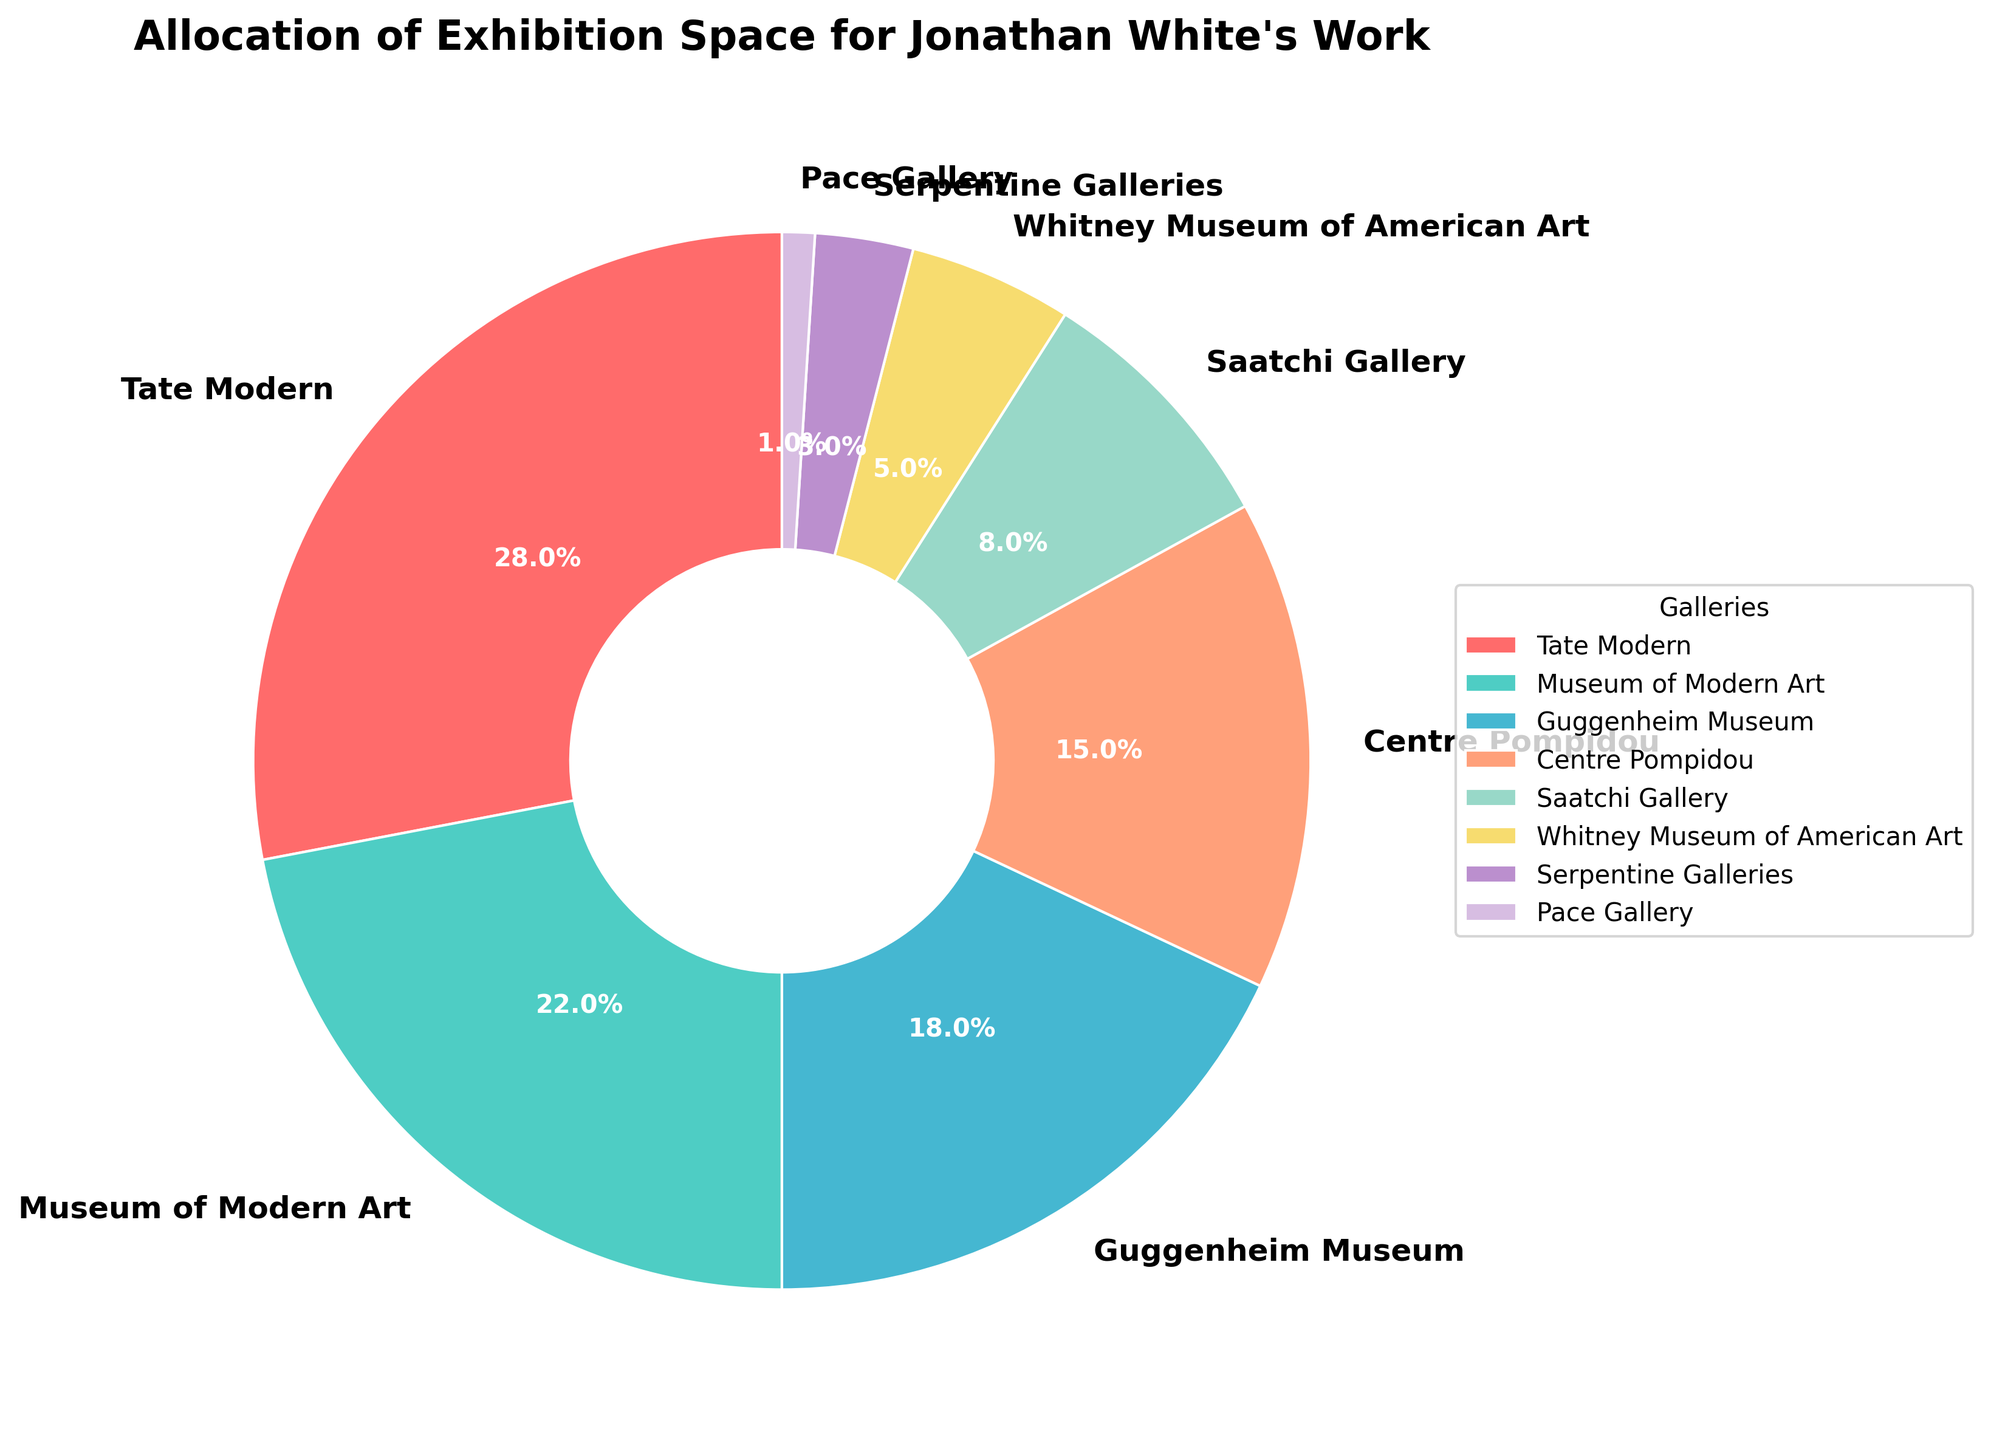Which gallery allocates the largest exhibition space for Jonathan White's work? We look for the gallery with the highest percentage allocation in the pie chart. The largest slice belongs to the Tate Modern, with 28%.
Answer: Tate Modern Which two galleries have a combined allocation of over 40%? By examining the pie chart, we see that Tate Modern has 28% and Museum of Modern Art has 22%. Summing these: 28% + 22% = 50%, which is over 40%.
Answer: Tate Modern and Museum of Modern Art How much more exhibition space does the Guggenheim Museum allocate compared to the Saatchi Gallery? Guggenheim Museum allocates 18%, and Saatchi Gallery allocates 8%. Subtracting these: 18% - 8% = 10%.
Answer: 10% What is the total percentage of space allocated by Whitney Museum, Serpentine Galleries, and Pace Gallery? Whitney Museum allocates 5%, Serpentine Galleries allocates 3%, and Pace Gallery allocates 1%. Summing these: 5% + 3% + 1% = 9%.
Answer: 9% Is the combined allocation of Centre Pompidou and Serpentine Galleries less than that of the Guggenheim Museum? Centre Pompidou allocates 15%, and Serpentine Galleries allocates 3%. Summing these: 15% + 3% = 18%, which is equal to the Guggenheim Museum’s 18%.
Answer: No Which gallery has the smallest exhibition space allocation, and what percentage is it? The smallest slice in the pie chart corresponds to the Pace Gallery, with 1%.
Answer: Pace Gallery, 1% What is the difference in the exhibition space allocation between the top three galleries and the bottom three galleries combined? Top three galleries: Tate Modern (28%), Museum of Modern Art (22%), Guggenheim Museum (18%) combine to: 28% + 22% + 18% = 68%. Bottom three galleries: Whitney Museum (5%), Serpentine Galleries (3%), Pace Gallery (1%) combine to: 5% + 3% + 1% = 9%. The difference is: 68% - 9% = 59%.
Answer: 59% 